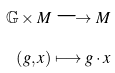Convert formula to latex. <formula><loc_0><loc_0><loc_500><loc_500>\mathbb { G } \times M \longrightarrow M \\ \left ( g , x \right ) \longmapsto g \cdot x</formula> 